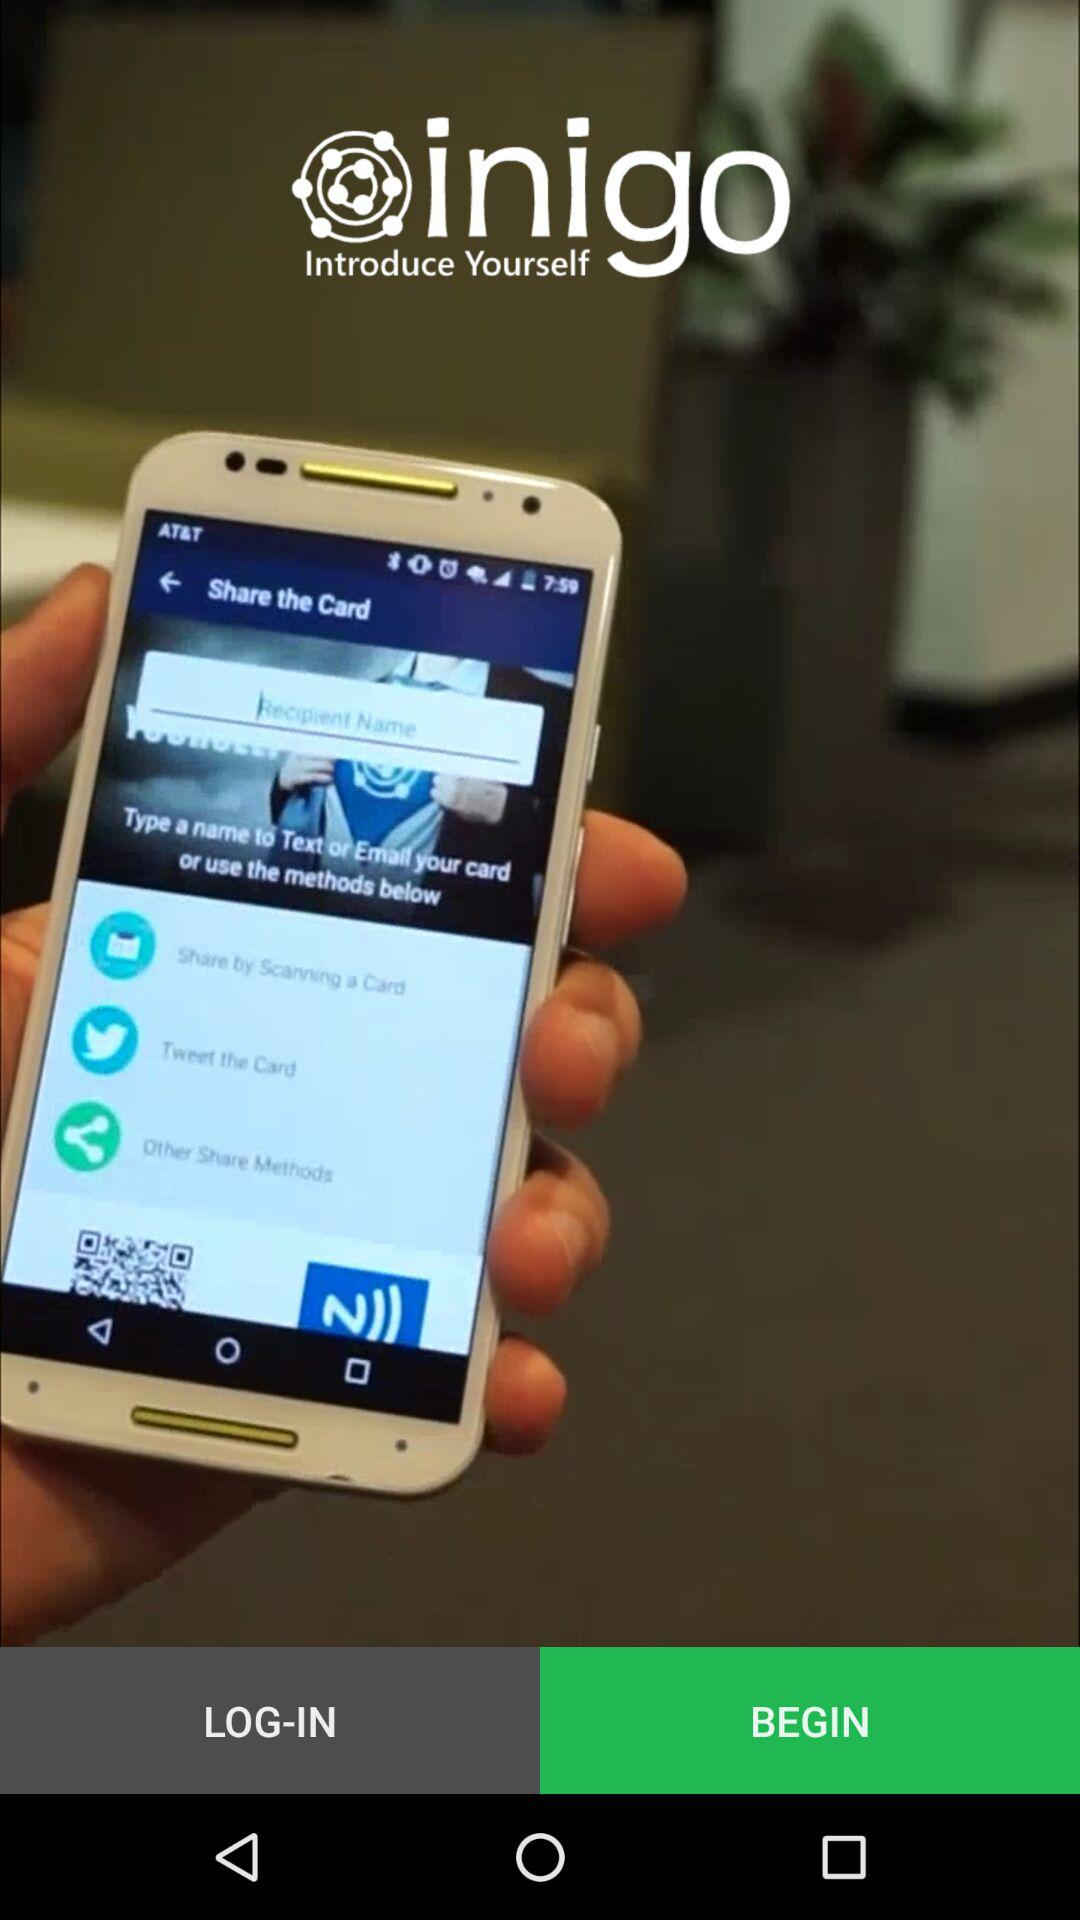Which Tab is selected?
When the provided information is insufficient, respond with <no answer>. <no answer> 